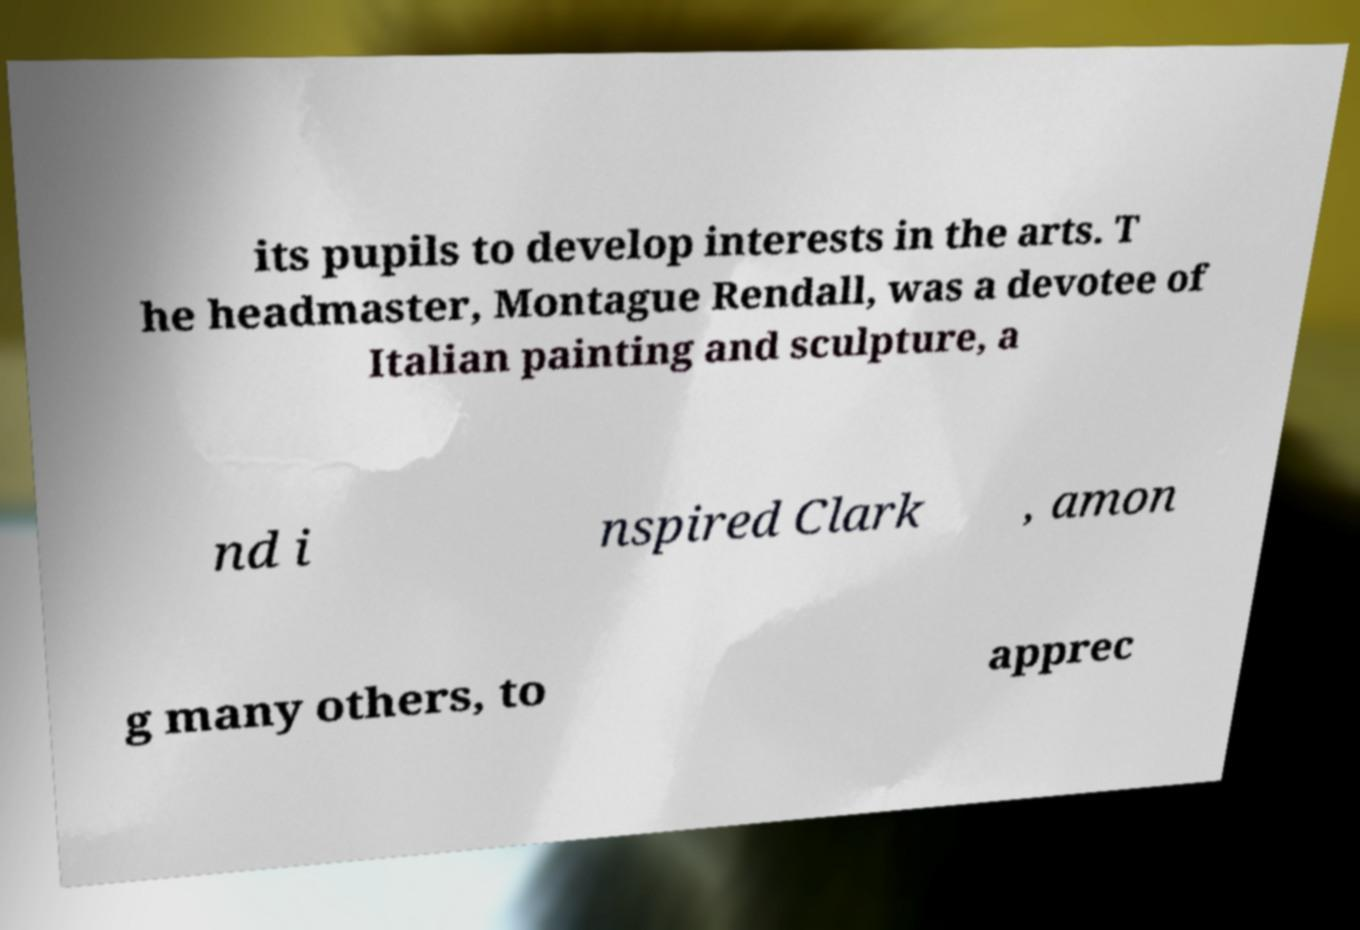Please read and relay the text visible in this image. What does it say? its pupils to develop interests in the arts. T he headmaster, Montague Rendall, was a devotee of Italian painting and sculpture, a nd i nspired Clark , amon g many others, to apprec 